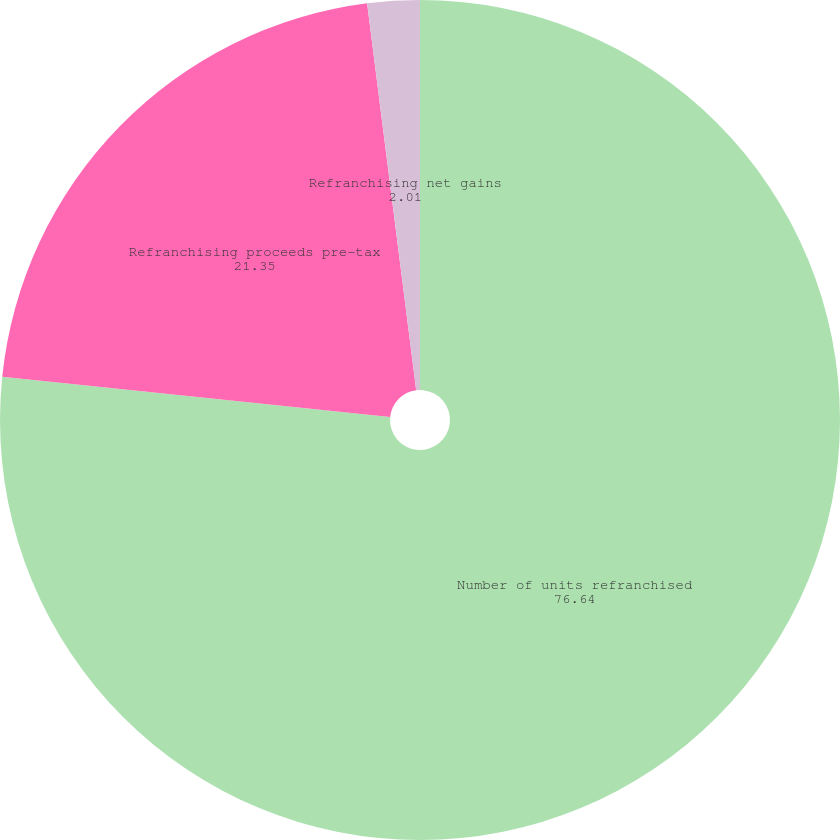<chart> <loc_0><loc_0><loc_500><loc_500><pie_chart><fcel>Number of units refranchised<fcel>Refranchising proceeds pre-tax<fcel>Refranchising net gains<nl><fcel>76.64%<fcel>21.35%<fcel>2.01%<nl></chart> 